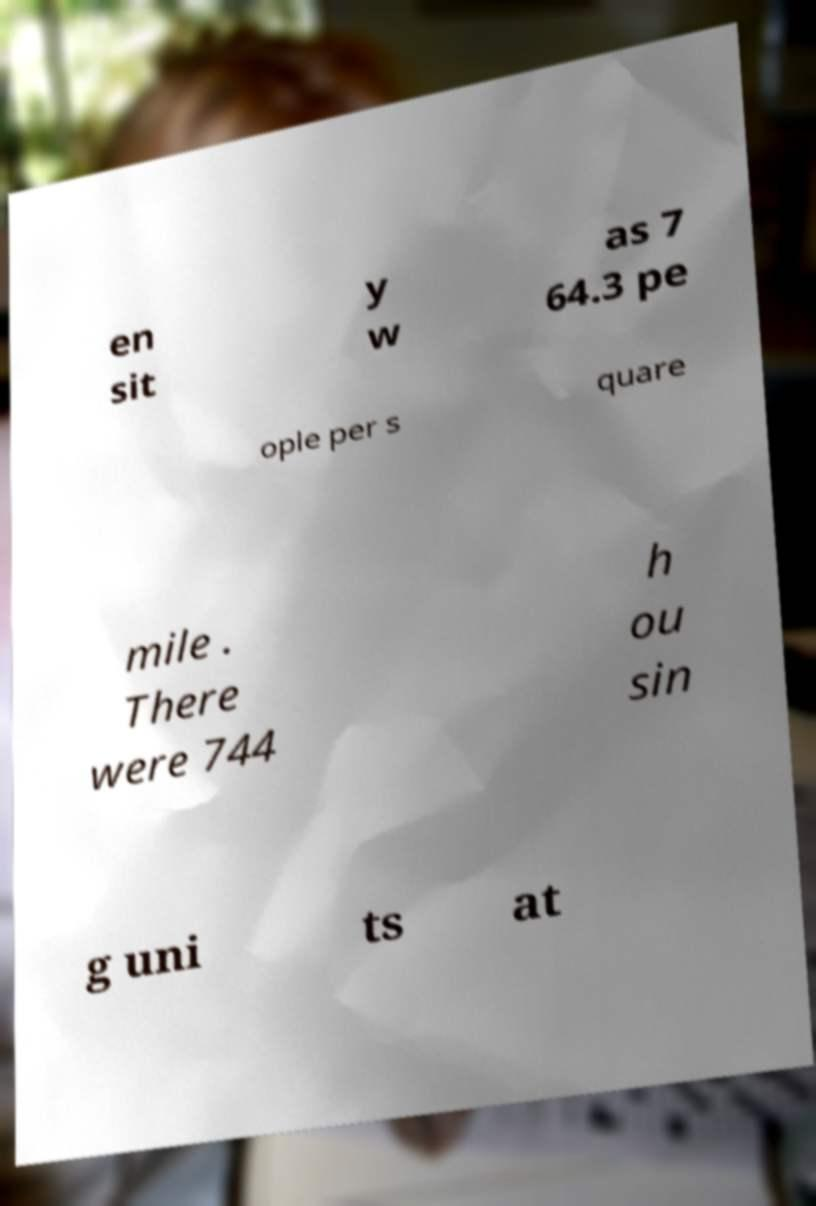I need the written content from this picture converted into text. Can you do that? en sit y w as 7 64.3 pe ople per s quare mile . There were 744 h ou sin g uni ts at 